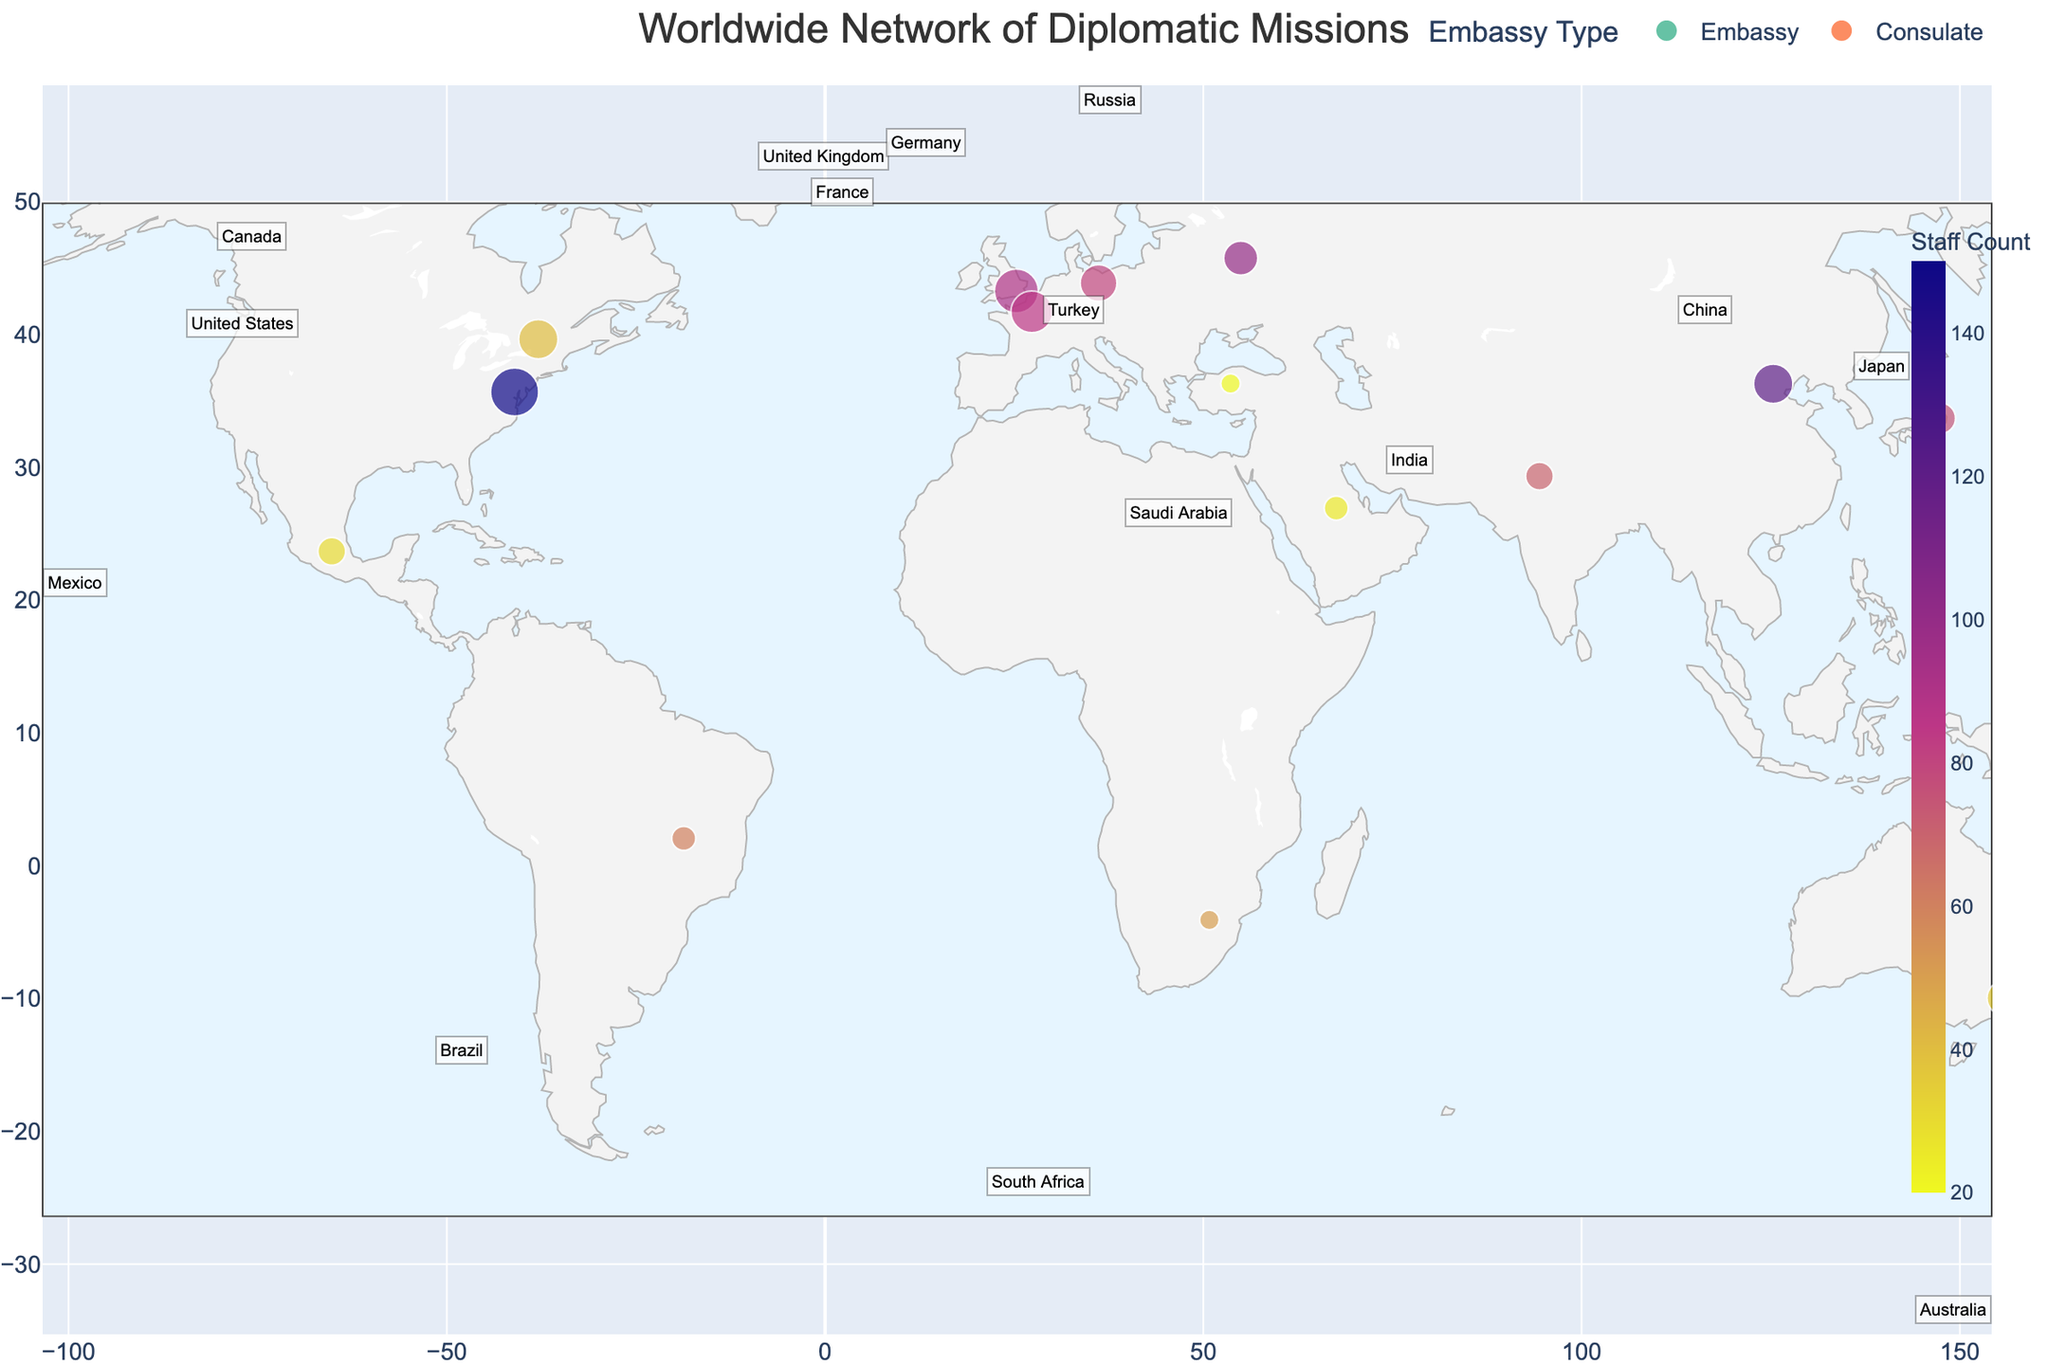Which country has the highest staff count in its embassy? Look at the data point with the largest color scale value. The largest staff count is represented by the darkest color. The United States has the darkest color, indicating the highest staff count.
Answer: United States Which countries have more than 10 bilateral agreements? Check for the size of the data points that exceed the threshold size representing 10 agreements. The data points for the United States and the United Kingdom are the largest, indicating they have more than 10 agreements.
Answer: United States, United Kingdom How does the number of staff in the embassy of China compare to that of Russia? Observe the color intensity of the data points for China and Russia. China's embassy has a darker color (indicating more staff) than Russia's.
Answer: China has more staff than Russia Which country has the smallest size data point on the map? Find the smallest data point which corresponds to the fewest bilateral agreements. South Africa and Turkey, both with 2 agreements, have the smallest data points.
Answer: South Africa, Turkey How many countries have consulates instead of embassies? Look at the legend that distinguishes embassies and consulates. The consulate data points (marked in different color by legend) are Canada, Australia, Mexico, Saudi Arabia, and Turkey.
Answer: 5 countries What is the average number of bilateral agreements for countries with embassies? First, sum the bilateral agreements of countries with embassies (12 + 8 + 6 + 10 + 9 + 7 + 5 + 4 + 3 + 2). Then, divide by the number of embassies which is 10. (12 + 8 + 6 + 10 + 9 + 7 + 5 + 4 + 3 + 2) = 66, and 66/10 = 6.6
Answer: 6.6 Comparing Brazil and India, which country has a higher staff count and fewer bilateral agreements? Look at the data points for Brazil and India. Brazil has a lighter color (indicating a lower staff count of 60) compared to India (70), and Brazil has fewer agreements (3) compared to India (4).
Answer: Brazil has fewer staff, fewer agreements Which region (continent) has the most concentrated cluster of data points? Observe the visual clustering of points on the map. Europe appears to have the most closely situated points (United Kingdom, France, Germany, Russia).
Answer: Europe What is the total staff count for all the countries combined? Sum the staff counts of all the countries. (150 + 120 + 100 + 90 + 85 + 80 + 75 + 70 + 60 + 50 + 40 + 35 + 30 + 25 + 20) = 1030
Answer: 1030 What is the distribution of countries between those with embassies and those with consulates? Count the number of countries with embassies and consulates as per the legend. There are 10 embassies and 5 consulates.
Answer: 10 embassies, 5 consulates 